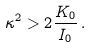<formula> <loc_0><loc_0><loc_500><loc_500>\kappa ^ { 2 } > 2 \frac { K _ { 0 } } { I _ { 0 } } \, .</formula> 